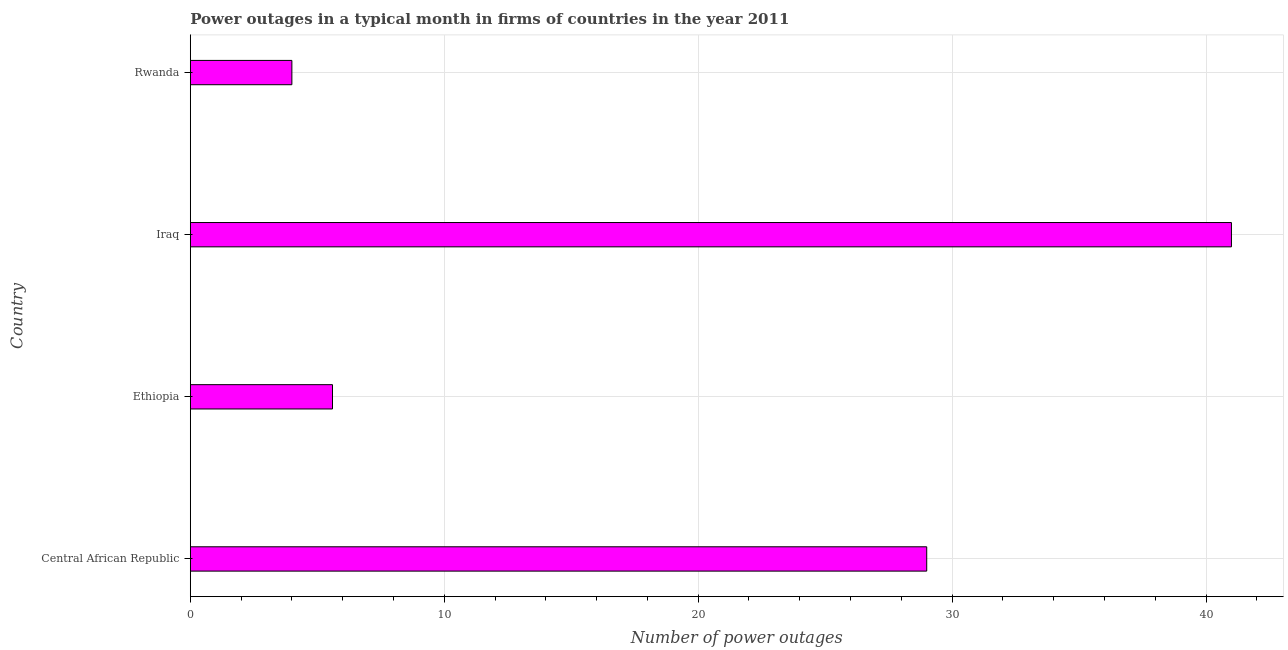What is the title of the graph?
Give a very brief answer. Power outages in a typical month in firms of countries in the year 2011. What is the label or title of the X-axis?
Offer a terse response. Number of power outages. What is the number of power outages in Ethiopia?
Your answer should be compact. 5.6. Across all countries, what is the maximum number of power outages?
Offer a terse response. 41. Across all countries, what is the minimum number of power outages?
Offer a very short reply. 4. In which country was the number of power outages maximum?
Your answer should be very brief. Iraq. In which country was the number of power outages minimum?
Your answer should be very brief. Rwanda. What is the sum of the number of power outages?
Ensure brevity in your answer.  79.6. In how many countries, is the number of power outages greater than 34 ?
Ensure brevity in your answer.  1. What is the ratio of the number of power outages in Iraq to that in Rwanda?
Offer a terse response. 10.25. Is the number of power outages in Central African Republic less than that in Iraq?
Give a very brief answer. Yes. Is the difference between the number of power outages in Iraq and Rwanda greater than the difference between any two countries?
Offer a terse response. Yes. What is the difference between the highest and the second highest number of power outages?
Your response must be concise. 12. In how many countries, is the number of power outages greater than the average number of power outages taken over all countries?
Ensure brevity in your answer.  2. How many bars are there?
Provide a succinct answer. 4. Are all the bars in the graph horizontal?
Provide a succinct answer. Yes. What is the difference between two consecutive major ticks on the X-axis?
Provide a short and direct response. 10. Are the values on the major ticks of X-axis written in scientific E-notation?
Your answer should be compact. No. What is the Number of power outages in Central African Republic?
Give a very brief answer. 29. What is the Number of power outages of Ethiopia?
Provide a succinct answer. 5.6. What is the difference between the Number of power outages in Central African Republic and Ethiopia?
Your answer should be compact. 23.4. What is the difference between the Number of power outages in Ethiopia and Iraq?
Provide a short and direct response. -35.4. What is the difference between the Number of power outages in Ethiopia and Rwanda?
Your response must be concise. 1.6. What is the difference between the Number of power outages in Iraq and Rwanda?
Keep it short and to the point. 37. What is the ratio of the Number of power outages in Central African Republic to that in Ethiopia?
Give a very brief answer. 5.18. What is the ratio of the Number of power outages in Central African Republic to that in Iraq?
Give a very brief answer. 0.71. What is the ratio of the Number of power outages in Central African Republic to that in Rwanda?
Make the answer very short. 7.25. What is the ratio of the Number of power outages in Ethiopia to that in Iraq?
Ensure brevity in your answer.  0.14. What is the ratio of the Number of power outages in Iraq to that in Rwanda?
Offer a very short reply. 10.25. 